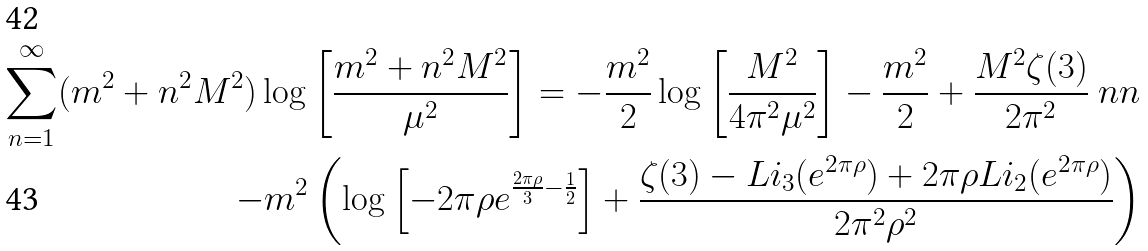<formula> <loc_0><loc_0><loc_500><loc_500>\sum _ { n = 1 } ^ { \infty } ( m ^ { 2 } + n ^ { 2 } M ^ { 2 } ) \log \left [ \frac { m ^ { 2 } + n ^ { 2 } M ^ { 2 } } { \mu ^ { 2 } } \right ] = - \frac { m ^ { 2 } } { 2 } \log \left [ \frac { M ^ { 2 } } { 4 \pi ^ { 2 } \mu ^ { 2 } } \right ] - \frac { m ^ { 2 } } { 2 } + \frac { M ^ { 2 } \zeta ( 3 ) } { 2 \pi ^ { 2 } } \ n n \\ - m ^ { 2 } \left ( \log \left [ - 2 \pi \rho e ^ { \frac { 2 \pi \rho } { 3 } - \frac { 1 } { 2 } } \right ] + \frac { \zeta ( 3 ) - L i _ { 3 } ( e ^ { 2 \pi \rho } ) + 2 \pi \rho L i _ { 2 } ( e ^ { 2 \pi \rho } ) } { 2 \pi ^ { 2 } \rho ^ { 2 } } \right )</formula> 